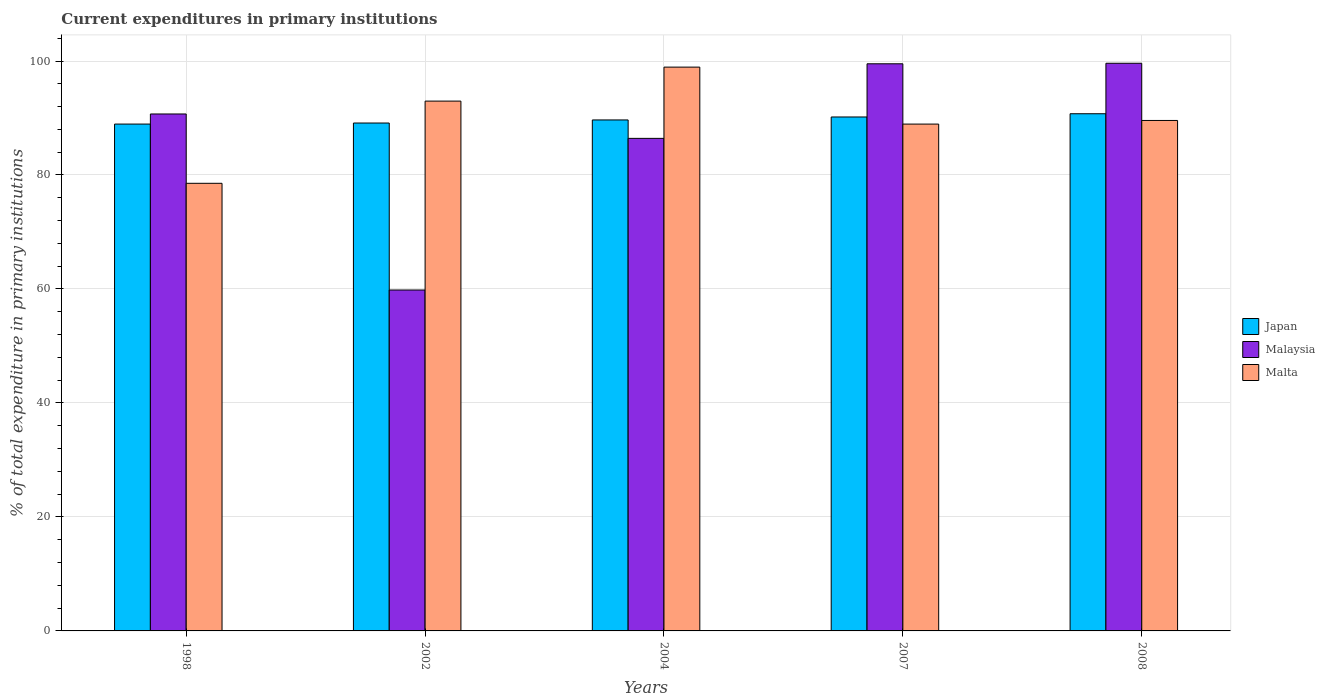How many different coloured bars are there?
Give a very brief answer. 3. How many bars are there on the 3rd tick from the left?
Give a very brief answer. 3. What is the current expenditures in primary institutions in Japan in 2008?
Provide a short and direct response. 90.75. Across all years, what is the maximum current expenditures in primary institutions in Malaysia?
Keep it short and to the point. 99.61. Across all years, what is the minimum current expenditures in primary institutions in Japan?
Offer a terse response. 88.93. In which year was the current expenditures in primary institutions in Malaysia maximum?
Your answer should be compact. 2008. In which year was the current expenditures in primary institutions in Malta minimum?
Offer a terse response. 1998. What is the total current expenditures in primary institutions in Japan in the graph?
Give a very brief answer. 448.64. What is the difference between the current expenditures in primary institutions in Japan in 1998 and that in 2002?
Keep it short and to the point. -0.18. What is the difference between the current expenditures in primary institutions in Malaysia in 2008 and the current expenditures in primary institutions in Japan in 1998?
Make the answer very short. 10.67. What is the average current expenditures in primary institutions in Malta per year?
Your answer should be compact. 89.79. In the year 2004, what is the difference between the current expenditures in primary institutions in Japan and current expenditures in primary institutions in Malta?
Offer a very short reply. -9.27. In how many years, is the current expenditures in primary institutions in Japan greater than 84 %?
Offer a terse response. 5. What is the ratio of the current expenditures in primary institutions in Japan in 2002 to that in 2007?
Provide a succinct answer. 0.99. Is the current expenditures in primary institutions in Malta in 2007 less than that in 2008?
Your answer should be very brief. Yes. Is the difference between the current expenditures in primary institutions in Japan in 2002 and 2004 greater than the difference between the current expenditures in primary institutions in Malta in 2002 and 2004?
Make the answer very short. Yes. What is the difference between the highest and the second highest current expenditures in primary institutions in Japan?
Make the answer very short. 0.57. What is the difference between the highest and the lowest current expenditures in primary institutions in Japan?
Offer a very short reply. 1.81. In how many years, is the current expenditures in primary institutions in Japan greater than the average current expenditures in primary institutions in Japan taken over all years?
Your answer should be compact. 2. What does the 3rd bar from the right in 2007 represents?
Your response must be concise. Japan. How many bars are there?
Provide a short and direct response. 15. Are the values on the major ticks of Y-axis written in scientific E-notation?
Provide a short and direct response. No. Does the graph contain any zero values?
Give a very brief answer. No. Where does the legend appear in the graph?
Your answer should be compact. Center right. How many legend labels are there?
Provide a short and direct response. 3. How are the legend labels stacked?
Keep it short and to the point. Vertical. What is the title of the graph?
Your response must be concise. Current expenditures in primary institutions. What is the label or title of the Y-axis?
Your answer should be compact. % of total expenditure in primary institutions. What is the % of total expenditure in primary institutions in Japan in 1998?
Ensure brevity in your answer.  88.93. What is the % of total expenditure in primary institutions of Malaysia in 1998?
Your answer should be compact. 90.71. What is the % of total expenditure in primary institutions of Malta in 1998?
Keep it short and to the point. 78.54. What is the % of total expenditure in primary institutions of Japan in 2002?
Offer a very short reply. 89.12. What is the % of total expenditure in primary institutions in Malaysia in 2002?
Your answer should be compact. 59.82. What is the % of total expenditure in primary institutions in Malta in 2002?
Provide a short and direct response. 92.96. What is the % of total expenditure in primary institutions of Japan in 2004?
Give a very brief answer. 89.66. What is the % of total expenditure in primary institutions of Malaysia in 2004?
Ensure brevity in your answer.  86.43. What is the % of total expenditure in primary institutions of Malta in 2004?
Offer a very short reply. 98.93. What is the % of total expenditure in primary institutions of Japan in 2007?
Offer a terse response. 90.18. What is the % of total expenditure in primary institutions in Malaysia in 2007?
Your answer should be compact. 99.51. What is the % of total expenditure in primary institutions of Malta in 2007?
Offer a very short reply. 88.93. What is the % of total expenditure in primary institutions of Japan in 2008?
Provide a short and direct response. 90.75. What is the % of total expenditure in primary institutions in Malaysia in 2008?
Keep it short and to the point. 99.61. What is the % of total expenditure in primary institutions of Malta in 2008?
Offer a terse response. 89.57. Across all years, what is the maximum % of total expenditure in primary institutions of Japan?
Your response must be concise. 90.75. Across all years, what is the maximum % of total expenditure in primary institutions of Malaysia?
Make the answer very short. 99.61. Across all years, what is the maximum % of total expenditure in primary institutions of Malta?
Offer a terse response. 98.93. Across all years, what is the minimum % of total expenditure in primary institutions in Japan?
Give a very brief answer. 88.93. Across all years, what is the minimum % of total expenditure in primary institutions in Malaysia?
Your response must be concise. 59.82. Across all years, what is the minimum % of total expenditure in primary institutions of Malta?
Offer a very short reply. 78.54. What is the total % of total expenditure in primary institutions of Japan in the graph?
Your answer should be compact. 448.64. What is the total % of total expenditure in primary institutions in Malaysia in the graph?
Provide a succinct answer. 436.07. What is the total % of total expenditure in primary institutions in Malta in the graph?
Provide a succinct answer. 448.94. What is the difference between the % of total expenditure in primary institutions in Japan in 1998 and that in 2002?
Ensure brevity in your answer.  -0.18. What is the difference between the % of total expenditure in primary institutions of Malaysia in 1998 and that in 2002?
Your response must be concise. 30.89. What is the difference between the % of total expenditure in primary institutions of Malta in 1998 and that in 2002?
Offer a very short reply. -14.42. What is the difference between the % of total expenditure in primary institutions in Japan in 1998 and that in 2004?
Your answer should be compact. -0.73. What is the difference between the % of total expenditure in primary institutions in Malaysia in 1998 and that in 2004?
Offer a terse response. 4.28. What is the difference between the % of total expenditure in primary institutions of Malta in 1998 and that in 2004?
Make the answer very short. -20.39. What is the difference between the % of total expenditure in primary institutions of Japan in 1998 and that in 2007?
Offer a terse response. -1.24. What is the difference between the % of total expenditure in primary institutions in Malaysia in 1998 and that in 2007?
Your response must be concise. -8.81. What is the difference between the % of total expenditure in primary institutions in Malta in 1998 and that in 2007?
Your answer should be very brief. -10.39. What is the difference between the % of total expenditure in primary institutions of Japan in 1998 and that in 2008?
Offer a very short reply. -1.81. What is the difference between the % of total expenditure in primary institutions in Malaysia in 1998 and that in 2008?
Ensure brevity in your answer.  -8.9. What is the difference between the % of total expenditure in primary institutions in Malta in 1998 and that in 2008?
Keep it short and to the point. -11.03. What is the difference between the % of total expenditure in primary institutions of Japan in 2002 and that in 2004?
Keep it short and to the point. -0.54. What is the difference between the % of total expenditure in primary institutions in Malaysia in 2002 and that in 2004?
Your answer should be very brief. -26.61. What is the difference between the % of total expenditure in primary institutions in Malta in 2002 and that in 2004?
Your response must be concise. -5.96. What is the difference between the % of total expenditure in primary institutions in Japan in 2002 and that in 2007?
Ensure brevity in your answer.  -1.06. What is the difference between the % of total expenditure in primary institutions of Malaysia in 2002 and that in 2007?
Make the answer very short. -39.69. What is the difference between the % of total expenditure in primary institutions of Malta in 2002 and that in 2007?
Provide a short and direct response. 4.03. What is the difference between the % of total expenditure in primary institutions of Japan in 2002 and that in 2008?
Your answer should be very brief. -1.63. What is the difference between the % of total expenditure in primary institutions of Malaysia in 2002 and that in 2008?
Ensure brevity in your answer.  -39.79. What is the difference between the % of total expenditure in primary institutions in Malta in 2002 and that in 2008?
Offer a very short reply. 3.39. What is the difference between the % of total expenditure in primary institutions in Japan in 2004 and that in 2007?
Your answer should be compact. -0.52. What is the difference between the % of total expenditure in primary institutions in Malaysia in 2004 and that in 2007?
Provide a succinct answer. -13.09. What is the difference between the % of total expenditure in primary institutions in Malta in 2004 and that in 2007?
Your response must be concise. 10. What is the difference between the % of total expenditure in primary institutions of Japan in 2004 and that in 2008?
Your response must be concise. -1.09. What is the difference between the % of total expenditure in primary institutions in Malaysia in 2004 and that in 2008?
Provide a succinct answer. -13.18. What is the difference between the % of total expenditure in primary institutions of Malta in 2004 and that in 2008?
Your answer should be compact. 9.36. What is the difference between the % of total expenditure in primary institutions in Japan in 2007 and that in 2008?
Your answer should be compact. -0.57. What is the difference between the % of total expenditure in primary institutions in Malaysia in 2007 and that in 2008?
Ensure brevity in your answer.  -0.09. What is the difference between the % of total expenditure in primary institutions of Malta in 2007 and that in 2008?
Provide a succinct answer. -0.64. What is the difference between the % of total expenditure in primary institutions of Japan in 1998 and the % of total expenditure in primary institutions of Malaysia in 2002?
Provide a succinct answer. 29.12. What is the difference between the % of total expenditure in primary institutions in Japan in 1998 and the % of total expenditure in primary institutions in Malta in 2002?
Your response must be concise. -4.03. What is the difference between the % of total expenditure in primary institutions of Malaysia in 1998 and the % of total expenditure in primary institutions of Malta in 2002?
Keep it short and to the point. -2.26. What is the difference between the % of total expenditure in primary institutions of Japan in 1998 and the % of total expenditure in primary institutions of Malaysia in 2004?
Make the answer very short. 2.51. What is the difference between the % of total expenditure in primary institutions in Japan in 1998 and the % of total expenditure in primary institutions in Malta in 2004?
Your answer should be compact. -9.99. What is the difference between the % of total expenditure in primary institutions of Malaysia in 1998 and the % of total expenditure in primary institutions of Malta in 2004?
Make the answer very short. -8.22. What is the difference between the % of total expenditure in primary institutions in Japan in 1998 and the % of total expenditure in primary institutions in Malaysia in 2007?
Offer a very short reply. -10.58. What is the difference between the % of total expenditure in primary institutions in Japan in 1998 and the % of total expenditure in primary institutions in Malta in 2007?
Offer a very short reply. 0. What is the difference between the % of total expenditure in primary institutions in Malaysia in 1998 and the % of total expenditure in primary institutions in Malta in 2007?
Offer a terse response. 1.77. What is the difference between the % of total expenditure in primary institutions of Japan in 1998 and the % of total expenditure in primary institutions of Malaysia in 2008?
Provide a succinct answer. -10.67. What is the difference between the % of total expenditure in primary institutions of Japan in 1998 and the % of total expenditure in primary institutions of Malta in 2008?
Make the answer very short. -0.64. What is the difference between the % of total expenditure in primary institutions in Malaysia in 1998 and the % of total expenditure in primary institutions in Malta in 2008?
Your answer should be compact. 1.14. What is the difference between the % of total expenditure in primary institutions of Japan in 2002 and the % of total expenditure in primary institutions of Malaysia in 2004?
Ensure brevity in your answer.  2.69. What is the difference between the % of total expenditure in primary institutions of Japan in 2002 and the % of total expenditure in primary institutions of Malta in 2004?
Your answer should be compact. -9.81. What is the difference between the % of total expenditure in primary institutions of Malaysia in 2002 and the % of total expenditure in primary institutions of Malta in 2004?
Provide a short and direct response. -39.11. What is the difference between the % of total expenditure in primary institutions in Japan in 2002 and the % of total expenditure in primary institutions in Malaysia in 2007?
Make the answer very short. -10.39. What is the difference between the % of total expenditure in primary institutions of Japan in 2002 and the % of total expenditure in primary institutions of Malta in 2007?
Your response must be concise. 0.19. What is the difference between the % of total expenditure in primary institutions in Malaysia in 2002 and the % of total expenditure in primary institutions in Malta in 2007?
Your answer should be compact. -29.11. What is the difference between the % of total expenditure in primary institutions in Japan in 2002 and the % of total expenditure in primary institutions in Malaysia in 2008?
Your answer should be very brief. -10.49. What is the difference between the % of total expenditure in primary institutions of Japan in 2002 and the % of total expenditure in primary institutions of Malta in 2008?
Keep it short and to the point. -0.45. What is the difference between the % of total expenditure in primary institutions of Malaysia in 2002 and the % of total expenditure in primary institutions of Malta in 2008?
Offer a terse response. -29.75. What is the difference between the % of total expenditure in primary institutions in Japan in 2004 and the % of total expenditure in primary institutions in Malaysia in 2007?
Ensure brevity in your answer.  -9.85. What is the difference between the % of total expenditure in primary institutions in Japan in 2004 and the % of total expenditure in primary institutions in Malta in 2007?
Ensure brevity in your answer.  0.73. What is the difference between the % of total expenditure in primary institutions in Malaysia in 2004 and the % of total expenditure in primary institutions in Malta in 2007?
Keep it short and to the point. -2.51. What is the difference between the % of total expenditure in primary institutions of Japan in 2004 and the % of total expenditure in primary institutions of Malaysia in 2008?
Provide a short and direct response. -9.95. What is the difference between the % of total expenditure in primary institutions in Japan in 2004 and the % of total expenditure in primary institutions in Malta in 2008?
Provide a succinct answer. 0.09. What is the difference between the % of total expenditure in primary institutions in Malaysia in 2004 and the % of total expenditure in primary institutions in Malta in 2008?
Make the answer very short. -3.14. What is the difference between the % of total expenditure in primary institutions of Japan in 2007 and the % of total expenditure in primary institutions of Malaysia in 2008?
Your response must be concise. -9.43. What is the difference between the % of total expenditure in primary institutions of Japan in 2007 and the % of total expenditure in primary institutions of Malta in 2008?
Your answer should be compact. 0.61. What is the difference between the % of total expenditure in primary institutions in Malaysia in 2007 and the % of total expenditure in primary institutions in Malta in 2008?
Offer a terse response. 9.94. What is the average % of total expenditure in primary institutions of Japan per year?
Ensure brevity in your answer.  89.73. What is the average % of total expenditure in primary institutions of Malaysia per year?
Give a very brief answer. 87.21. What is the average % of total expenditure in primary institutions of Malta per year?
Give a very brief answer. 89.79. In the year 1998, what is the difference between the % of total expenditure in primary institutions of Japan and % of total expenditure in primary institutions of Malaysia?
Keep it short and to the point. -1.77. In the year 1998, what is the difference between the % of total expenditure in primary institutions in Japan and % of total expenditure in primary institutions in Malta?
Provide a succinct answer. 10.39. In the year 1998, what is the difference between the % of total expenditure in primary institutions in Malaysia and % of total expenditure in primary institutions in Malta?
Offer a very short reply. 12.16. In the year 2002, what is the difference between the % of total expenditure in primary institutions in Japan and % of total expenditure in primary institutions in Malaysia?
Keep it short and to the point. 29.3. In the year 2002, what is the difference between the % of total expenditure in primary institutions of Japan and % of total expenditure in primary institutions of Malta?
Your response must be concise. -3.85. In the year 2002, what is the difference between the % of total expenditure in primary institutions of Malaysia and % of total expenditure in primary institutions of Malta?
Ensure brevity in your answer.  -33.15. In the year 2004, what is the difference between the % of total expenditure in primary institutions in Japan and % of total expenditure in primary institutions in Malaysia?
Offer a terse response. 3.23. In the year 2004, what is the difference between the % of total expenditure in primary institutions of Japan and % of total expenditure in primary institutions of Malta?
Keep it short and to the point. -9.27. In the year 2004, what is the difference between the % of total expenditure in primary institutions of Malaysia and % of total expenditure in primary institutions of Malta?
Your answer should be very brief. -12.5. In the year 2007, what is the difference between the % of total expenditure in primary institutions of Japan and % of total expenditure in primary institutions of Malaysia?
Ensure brevity in your answer.  -9.33. In the year 2007, what is the difference between the % of total expenditure in primary institutions of Japan and % of total expenditure in primary institutions of Malta?
Make the answer very short. 1.25. In the year 2007, what is the difference between the % of total expenditure in primary institutions in Malaysia and % of total expenditure in primary institutions in Malta?
Give a very brief answer. 10.58. In the year 2008, what is the difference between the % of total expenditure in primary institutions of Japan and % of total expenditure in primary institutions of Malaysia?
Keep it short and to the point. -8.86. In the year 2008, what is the difference between the % of total expenditure in primary institutions in Japan and % of total expenditure in primary institutions in Malta?
Give a very brief answer. 1.18. In the year 2008, what is the difference between the % of total expenditure in primary institutions in Malaysia and % of total expenditure in primary institutions in Malta?
Provide a short and direct response. 10.04. What is the ratio of the % of total expenditure in primary institutions of Japan in 1998 to that in 2002?
Offer a terse response. 1. What is the ratio of the % of total expenditure in primary institutions in Malaysia in 1998 to that in 2002?
Provide a succinct answer. 1.52. What is the ratio of the % of total expenditure in primary institutions in Malta in 1998 to that in 2002?
Ensure brevity in your answer.  0.84. What is the ratio of the % of total expenditure in primary institutions of Japan in 1998 to that in 2004?
Ensure brevity in your answer.  0.99. What is the ratio of the % of total expenditure in primary institutions of Malaysia in 1998 to that in 2004?
Ensure brevity in your answer.  1.05. What is the ratio of the % of total expenditure in primary institutions in Malta in 1998 to that in 2004?
Your response must be concise. 0.79. What is the ratio of the % of total expenditure in primary institutions of Japan in 1998 to that in 2007?
Provide a succinct answer. 0.99. What is the ratio of the % of total expenditure in primary institutions in Malaysia in 1998 to that in 2007?
Make the answer very short. 0.91. What is the ratio of the % of total expenditure in primary institutions in Malta in 1998 to that in 2007?
Provide a succinct answer. 0.88. What is the ratio of the % of total expenditure in primary institutions of Malaysia in 1998 to that in 2008?
Offer a terse response. 0.91. What is the ratio of the % of total expenditure in primary institutions in Malta in 1998 to that in 2008?
Make the answer very short. 0.88. What is the ratio of the % of total expenditure in primary institutions in Japan in 2002 to that in 2004?
Ensure brevity in your answer.  0.99. What is the ratio of the % of total expenditure in primary institutions of Malaysia in 2002 to that in 2004?
Your answer should be very brief. 0.69. What is the ratio of the % of total expenditure in primary institutions in Malta in 2002 to that in 2004?
Provide a succinct answer. 0.94. What is the ratio of the % of total expenditure in primary institutions of Japan in 2002 to that in 2007?
Make the answer very short. 0.99. What is the ratio of the % of total expenditure in primary institutions in Malaysia in 2002 to that in 2007?
Give a very brief answer. 0.6. What is the ratio of the % of total expenditure in primary institutions of Malta in 2002 to that in 2007?
Provide a succinct answer. 1.05. What is the ratio of the % of total expenditure in primary institutions in Japan in 2002 to that in 2008?
Provide a short and direct response. 0.98. What is the ratio of the % of total expenditure in primary institutions of Malaysia in 2002 to that in 2008?
Your answer should be very brief. 0.6. What is the ratio of the % of total expenditure in primary institutions of Malta in 2002 to that in 2008?
Provide a succinct answer. 1.04. What is the ratio of the % of total expenditure in primary institutions of Japan in 2004 to that in 2007?
Offer a terse response. 0.99. What is the ratio of the % of total expenditure in primary institutions in Malaysia in 2004 to that in 2007?
Your answer should be compact. 0.87. What is the ratio of the % of total expenditure in primary institutions in Malta in 2004 to that in 2007?
Your response must be concise. 1.11. What is the ratio of the % of total expenditure in primary institutions of Malaysia in 2004 to that in 2008?
Keep it short and to the point. 0.87. What is the ratio of the % of total expenditure in primary institutions in Malta in 2004 to that in 2008?
Provide a short and direct response. 1.1. What is the difference between the highest and the second highest % of total expenditure in primary institutions of Japan?
Give a very brief answer. 0.57. What is the difference between the highest and the second highest % of total expenditure in primary institutions in Malaysia?
Offer a very short reply. 0.09. What is the difference between the highest and the second highest % of total expenditure in primary institutions in Malta?
Your response must be concise. 5.96. What is the difference between the highest and the lowest % of total expenditure in primary institutions in Japan?
Your answer should be compact. 1.81. What is the difference between the highest and the lowest % of total expenditure in primary institutions in Malaysia?
Your answer should be very brief. 39.79. What is the difference between the highest and the lowest % of total expenditure in primary institutions in Malta?
Your answer should be compact. 20.39. 